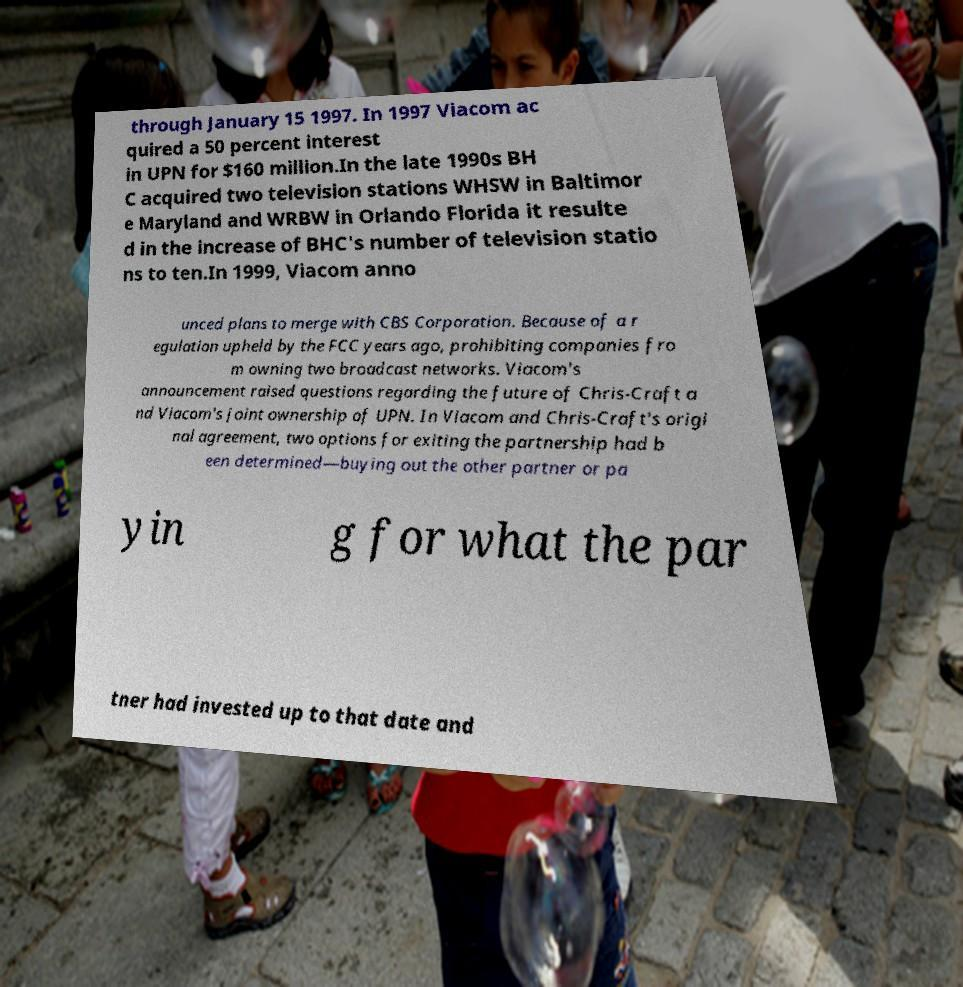Could you assist in decoding the text presented in this image and type it out clearly? through January 15 1997. In 1997 Viacom ac quired a 50 percent interest in UPN for $160 million.In the late 1990s BH C acquired two television stations WHSW in Baltimor e Maryland and WRBW in Orlando Florida it resulte d in the increase of BHC's number of television statio ns to ten.In 1999, Viacom anno unced plans to merge with CBS Corporation. Because of a r egulation upheld by the FCC years ago, prohibiting companies fro m owning two broadcast networks. Viacom's announcement raised questions regarding the future of Chris-Craft a nd Viacom's joint ownership of UPN. In Viacom and Chris-Craft's origi nal agreement, two options for exiting the partnership had b een determined—buying out the other partner or pa yin g for what the par tner had invested up to that date and 